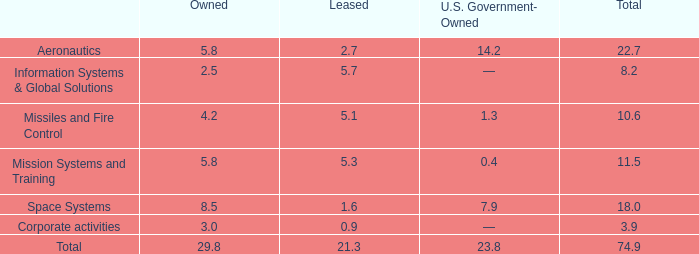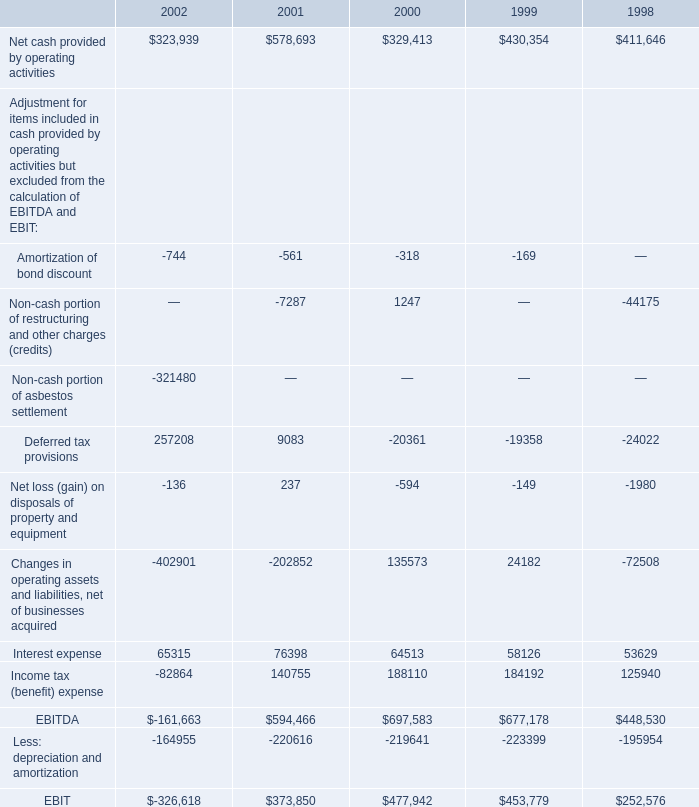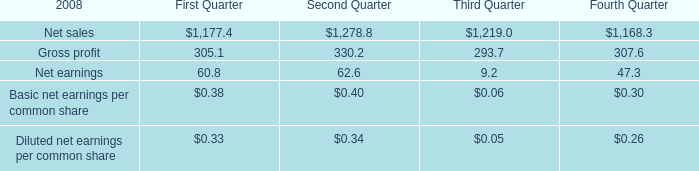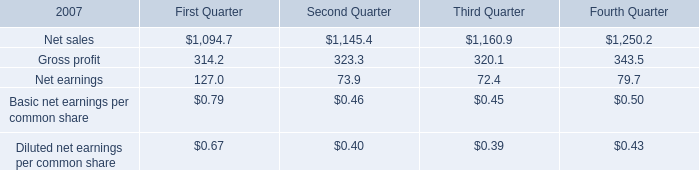What is the sum of Net sales of First Quarter, and Net cash provided by operating activities of 2000 ? 
Computations: (1094.7 + 329413.0)
Answer: 330507.7. 